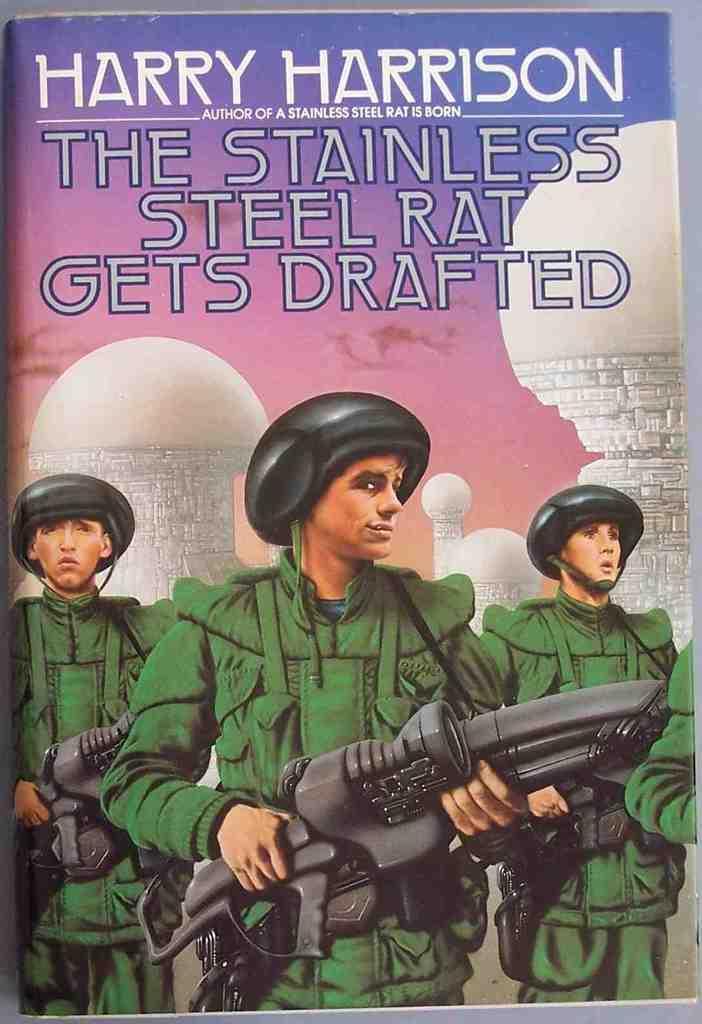How would you summarize this image in a sentence or two? It is an image on the book, there are 3 men holding the weapons, wearing green color coats and helmets. 